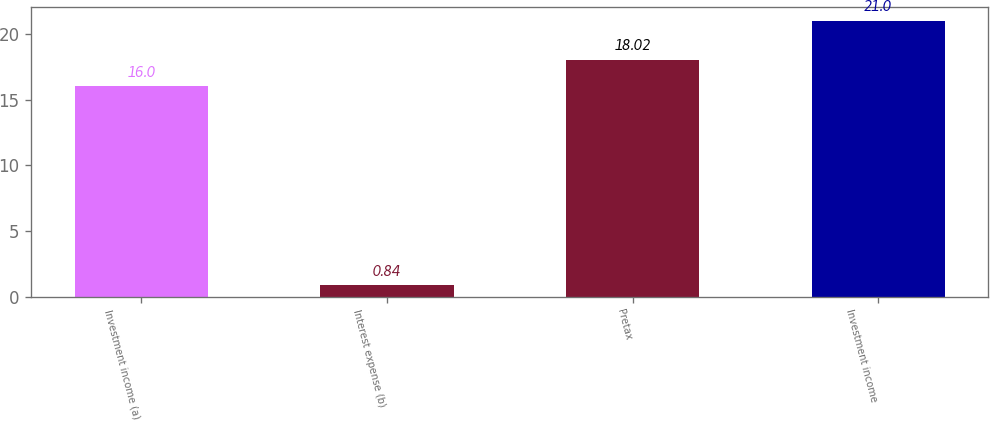<chart> <loc_0><loc_0><loc_500><loc_500><bar_chart><fcel>Investment income (a)<fcel>Interest expense (b)<fcel>Pretax<fcel>Investment income<nl><fcel>16<fcel>0.84<fcel>18.02<fcel>21<nl></chart> 